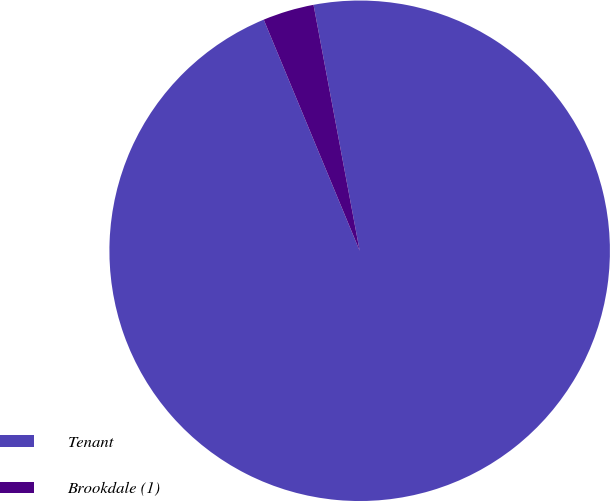Convert chart. <chart><loc_0><loc_0><loc_500><loc_500><pie_chart><fcel>Tenant<fcel>Brookdale (1)<nl><fcel>96.69%<fcel>3.31%<nl></chart> 